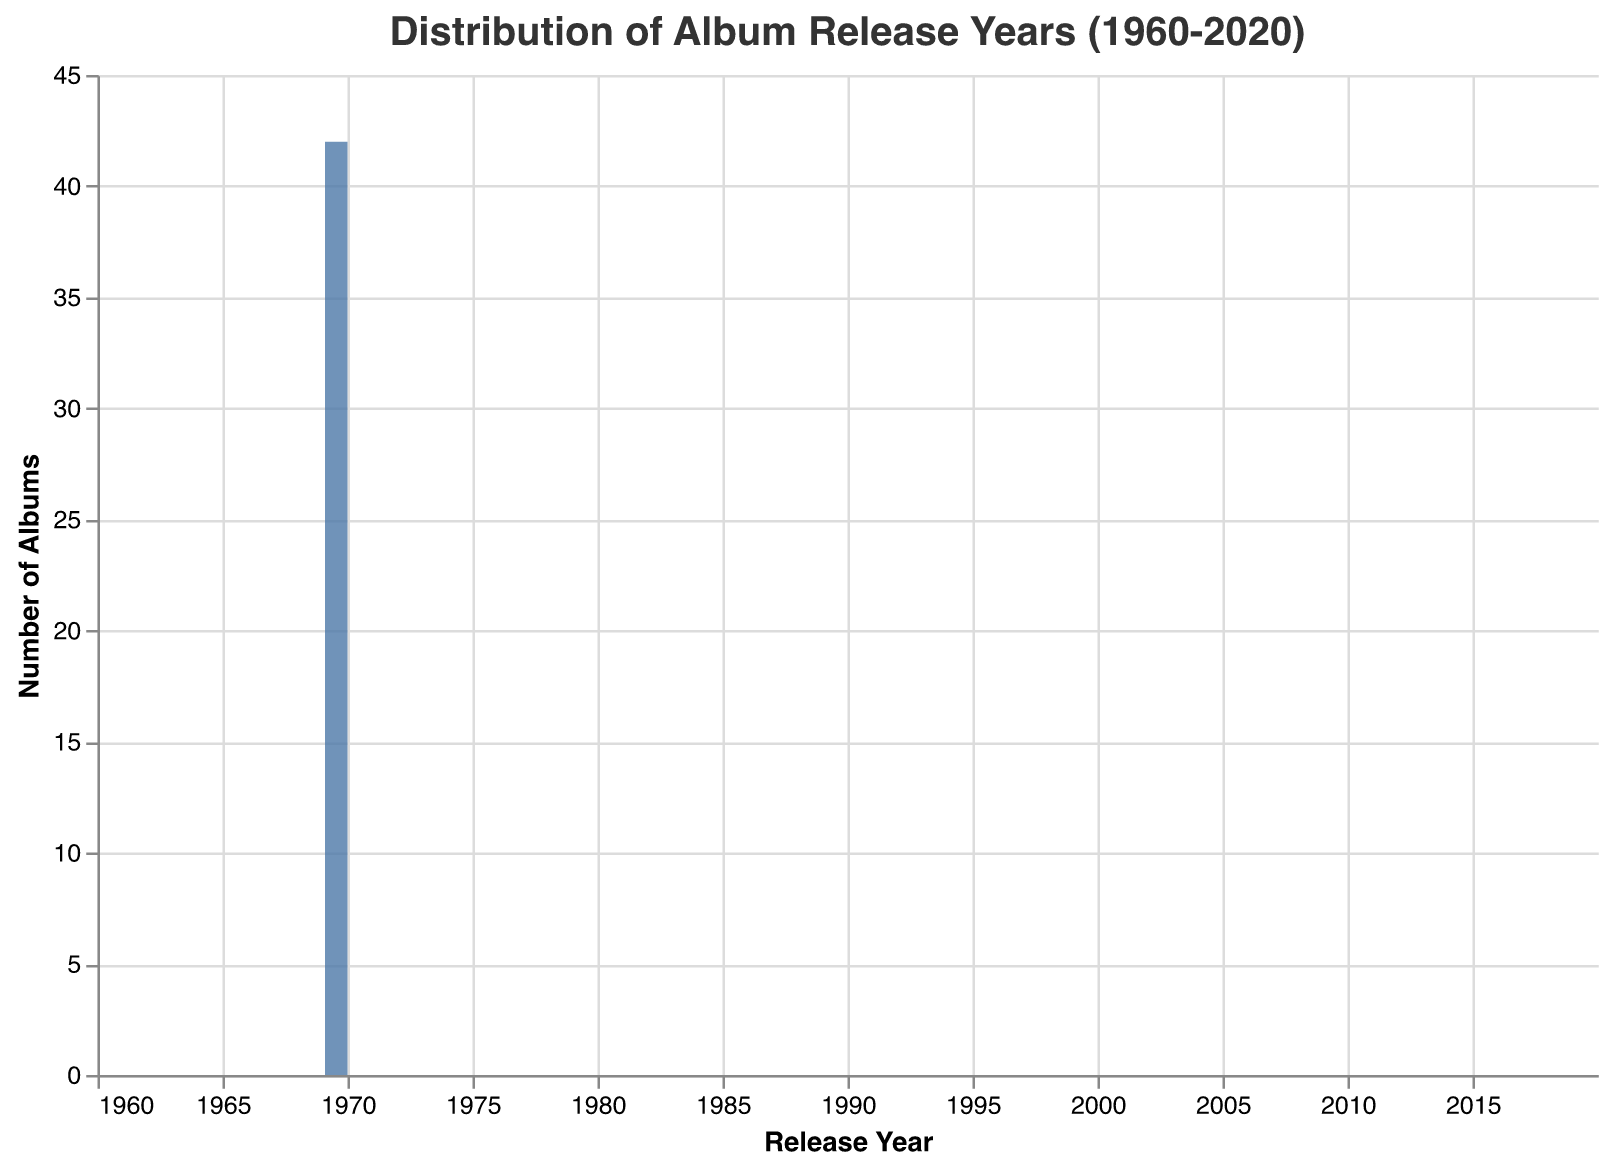What is the title of the chart? The title is found at the top of the chart. It states what the chart represents, which in this case is about album release years.
Answer: Distribution of Album Release Years (1960-2020) What range of years does the x-axis represent? The x-axis shows the distribution of album release years, and it ranges from 1960 to 2020, which can be seen at the endpoints of the horizontal axis.
Answer: 1960 to 2020 Which decade has the highest number of album releases in the chart? Look at the tallest bar on the chart and check the corresponding range on the x-axis.
Answer: 1970s How many albums were released in the 1980s? Count the height of the bars for the years 1980s which roughly spans from 1980 to 1989. Sum the counts from these bars.
Answer: 9 Are there more albums released in the 2000s or the 2010s? Compare the heights of the bars for the respective decades. The taller collection of bars would indicate more album releases.
Answer: 2000s Which year had the fewest album releases? Identify the shortest bar in the chart and note its corresponding year on the x-axis.
Answer: 2011 Is there a noticeable trend in album releases over the years? Observe the general shape of the histogram to identify any patterns. Notice if there's an upward or downward trend or if the number of album releases is stable over the years.
Answer: Peaks in the 1970s and 1980s; relatively fewer releases in other years What is the total number of albums released as shown in the chart? Sum the heights of all the bars in the chart to get the total count.
Answer: 44 How many albums were released in 1973? Locate the bar for the year 1973 on the x-axis and note the height of the bar to find the number of albums released that year.
Answer: 2 